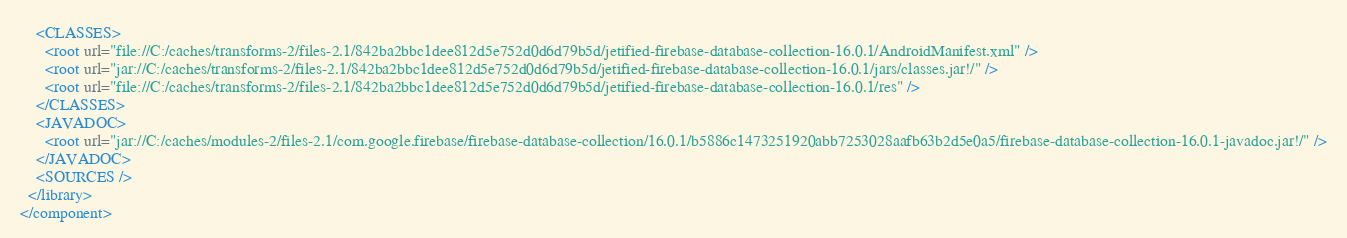Convert code to text. <code><loc_0><loc_0><loc_500><loc_500><_XML_>    <CLASSES>
      <root url="file://C:/caches/transforms-2/files-2.1/842ba2bbc1dee812d5e752d0d6d79b5d/jetified-firebase-database-collection-16.0.1/AndroidManifest.xml" />
      <root url="jar://C:/caches/transforms-2/files-2.1/842ba2bbc1dee812d5e752d0d6d79b5d/jetified-firebase-database-collection-16.0.1/jars/classes.jar!/" />
      <root url="file://C:/caches/transforms-2/files-2.1/842ba2bbc1dee812d5e752d0d6d79b5d/jetified-firebase-database-collection-16.0.1/res" />
    </CLASSES>
    <JAVADOC>
      <root url="jar://C:/caches/modules-2/files-2.1/com.google.firebase/firebase-database-collection/16.0.1/b5886c1473251920abb7253028aafb63b2d5e0a5/firebase-database-collection-16.0.1-javadoc.jar!/" />
    </JAVADOC>
    <SOURCES />
  </library>
</component></code> 